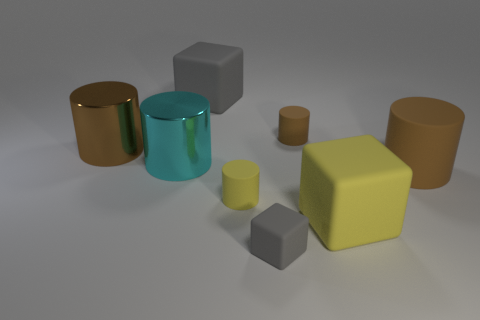There is a rubber thing that is the same color as the small block; what is its shape?
Offer a terse response. Cube. There is a rubber cylinder that is behind the brown metal thing; how big is it?
Your answer should be compact. Small. What number of purple objects are either cylinders or small metallic spheres?
Make the answer very short. 0. What is the material of the other gray thing that is the same shape as the large gray object?
Your answer should be very brief. Rubber. Is the number of big matte objects in front of the big brown shiny object the same as the number of gray things?
Give a very brief answer. Yes. What is the size of the rubber thing that is both to the left of the small gray thing and in front of the large gray matte cube?
Your answer should be compact. Small. Is there any other thing of the same color as the small rubber cube?
Your response must be concise. Yes. There is a gray matte block behind the large rubber object that is in front of the big rubber cylinder; what size is it?
Ensure brevity in your answer.  Large. The cylinder that is both right of the cyan shiny object and behind the cyan shiny cylinder is what color?
Give a very brief answer. Brown. What number of other objects are there of the same size as the yellow rubber cylinder?
Provide a short and direct response. 2. 